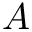Convert formula to latex. <formula><loc_0><loc_0><loc_500><loc_500>A</formula> 